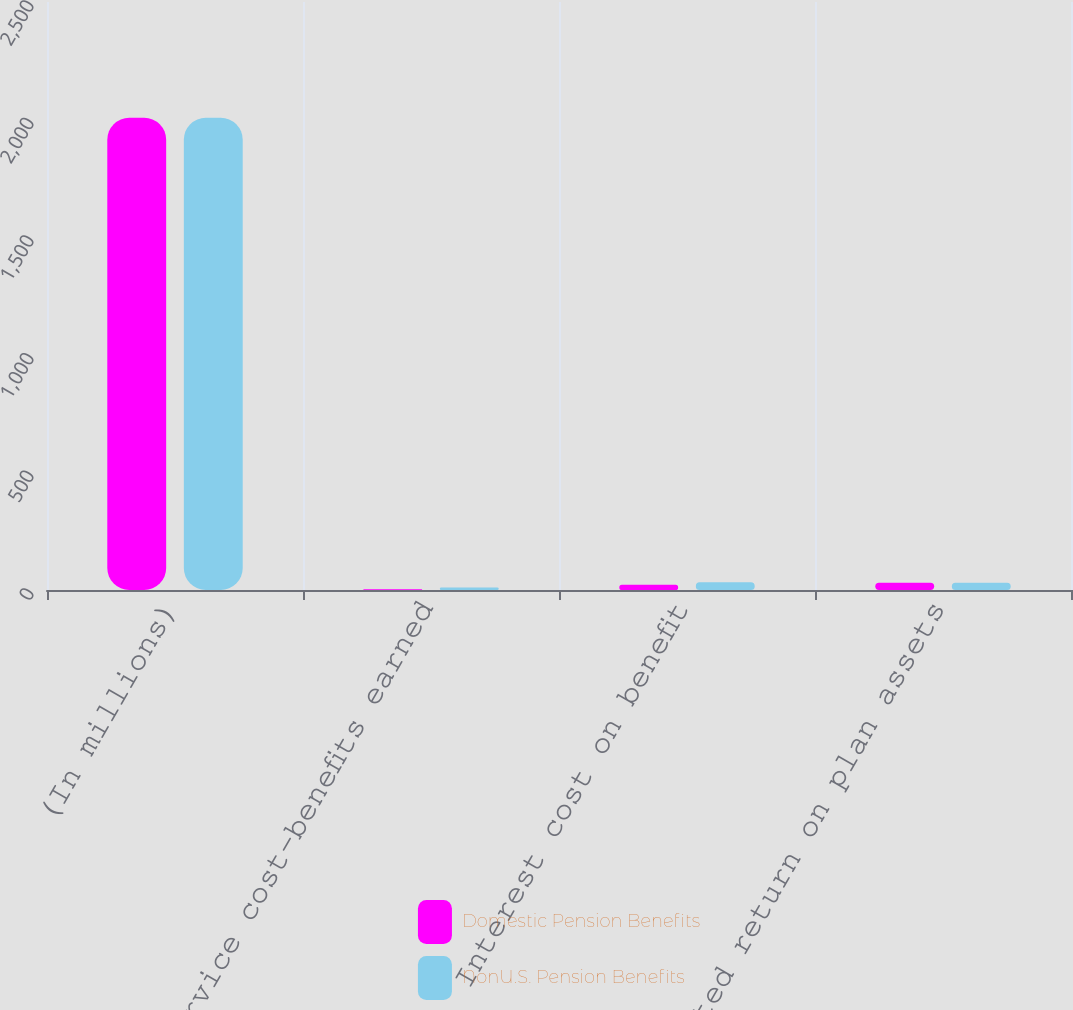<chart> <loc_0><loc_0><loc_500><loc_500><stacked_bar_chart><ecel><fcel>(In millions)<fcel>Service cost-benefits earned<fcel>Interest cost on benefit<fcel>Expected return on plan assets<nl><fcel>Domestic Pension Benefits<fcel>2008<fcel>2.9<fcel>22<fcel>31.1<nl><fcel>NonU.S. Pension Benefits<fcel>2008<fcel>10.9<fcel>32.8<fcel>30.4<nl></chart> 